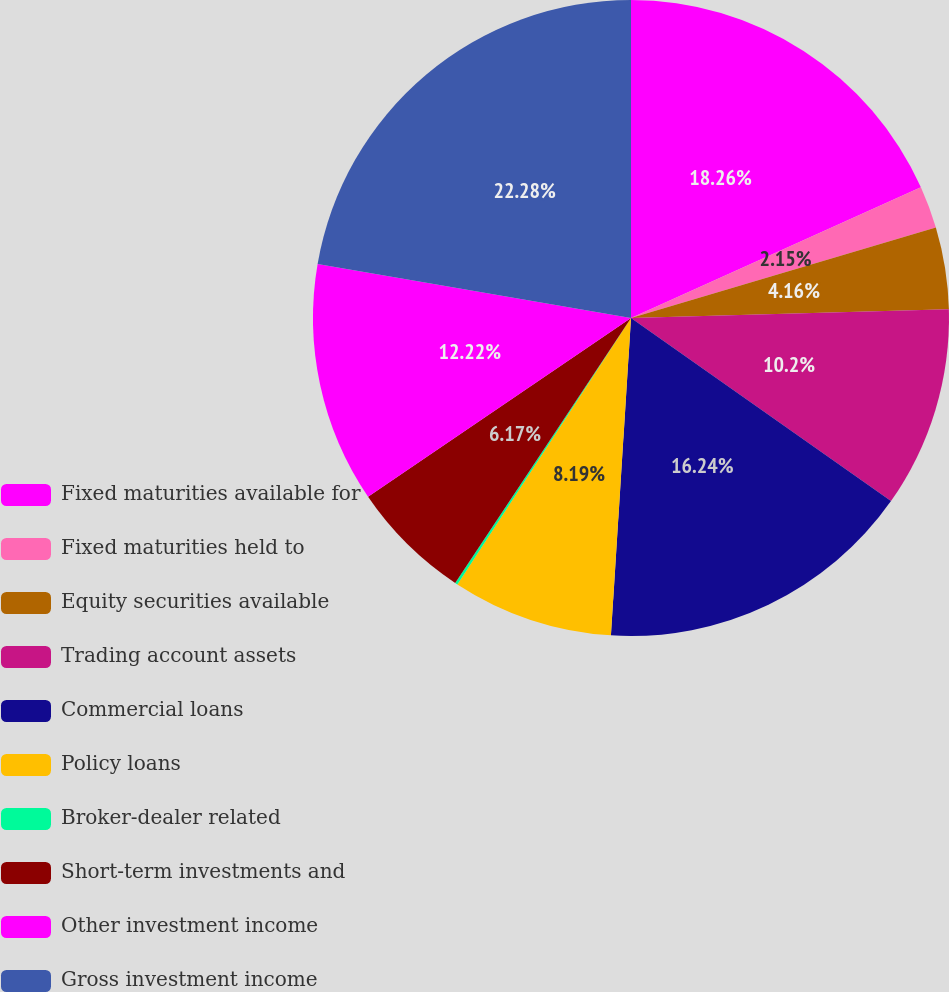Convert chart. <chart><loc_0><loc_0><loc_500><loc_500><pie_chart><fcel>Fixed maturities available for<fcel>Fixed maturities held to<fcel>Equity securities available<fcel>Trading account assets<fcel>Commercial loans<fcel>Policy loans<fcel>Broker-dealer related<fcel>Short-term investments and<fcel>Other investment income<fcel>Gross investment income<nl><fcel>18.26%<fcel>2.15%<fcel>4.16%<fcel>10.2%<fcel>16.24%<fcel>8.19%<fcel>0.13%<fcel>6.17%<fcel>12.22%<fcel>22.29%<nl></chart> 